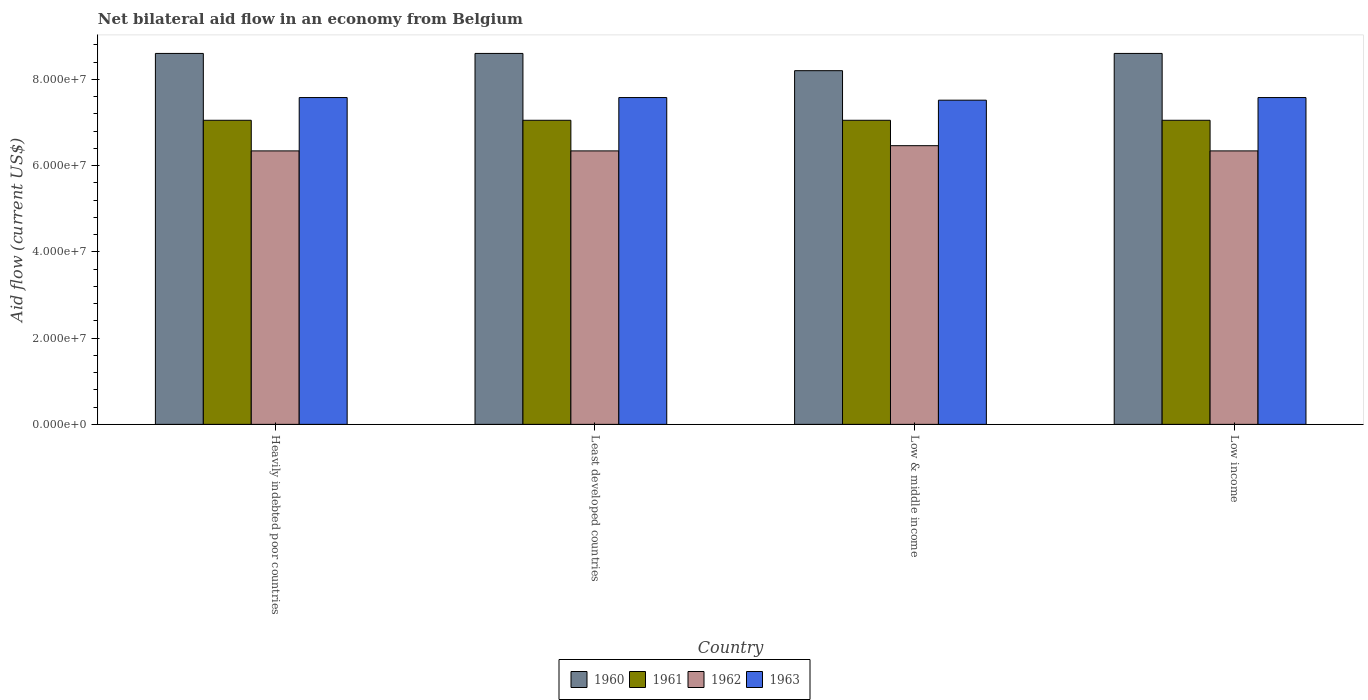How many different coloured bars are there?
Your answer should be compact. 4. Are the number of bars on each tick of the X-axis equal?
Ensure brevity in your answer.  Yes. How many bars are there on the 1st tick from the left?
Your answer should be compact. 4. How many bars are there on the 3rd tick from the right?
Your response must be concise. 4. What is the label of the 1st group of bars from the left?
Your response must be concise. Heavily indebted poor countries. In how many cases, is the number of bars for a given country not equal to the number of legend labels?
Provide a short and direct response. 0. What is the net bilateral aid flow in 1962 in Least developed countries?
Your response must be concise. 6.34e+07. Across all countries, what is the maximum net bilateral aid flow in 1961?
Ensure brevity in your answer.  7.05e+07. Across all countries, what is the minimum net bilateral aid flow in 1963?
Ensure brevity in your answer.  7.52e+07. In which country was the net bilateral aid flow in 1962 maximum?
Ensure brevity in your answer.  Low & middle income. What is the total net bilateral aid flow in 1963 in the graph?
Give a very brief answer. 3.02e+08. What is the difference between the net bilateral aid flow in 1962 in Low & middle income and the net bilateral aid flow in 1961 in Heavily indebted poor countries?
Offer a terse response. -5.89e+06. What is the average net bilateral aid flow in 1961 per country?
Keep it short and to the point. 7.05e+07. What is the difference between the net bilateral aid flow of/in 1961 and net bilateral aid flow of/in 1960 in Low & middle income?
Provide a succinct answer. -1.15e+07. In how many countries, is the net bilateral aid flow in 1960 greater than 52000000 US$?
Your response must be concise. 4. Is the net bilateral aid flow in 1962 in Least developed countries less than that in Low & middle income?
Offer a terse response. Yes. What is the difference between the highest and the second highest net bilateral aid flow in 1962?
Your response must be concise. 1.21e+06. What is the difference between the highest and the lowest net bilateral aid flow in 1961?
Your answer should be compact. 0. In how many countries, is the net bilateral aid flow in 1961 greater than the average net bilateral aid flow in 1961 taken over all countries?
Provide a short and direct response. 0. Is the sum of the net bilateral aid flow in 1962 in Low & middle income and Low income greater than the maximum net bilateral aid flow in 1961 across all countries?
Provide a short and direct response. Yes. What does the 4th bar from the left in Least developed countries represents?
Your response must be concise. 1963. How many bars are there?
Make the answer very short. 16. Are all the bars in the graph horizontal?
Keep it short and to the point. No. How many countries are there in the graph?
Your response must be concise. 4. Does the graph contain any zero values?
Keep it short and to the point. No. What is the title of the graph?
Your answer should be compact. Net bilateral aid flow in an economy from Belgium. Does "2000" appear as one of the legend labels in the graph?
Provide a succinct answer. No. What is the label or title of the X-axis?
Your answer should be compact. Country. What is the Aid flow (current US$) of 1960 in Heavily indebted poor countries?
Ensure brevity in your answer.  8.60e+07. What is the Aid flow (current US$) of 1961 in Heavily indebted poor countries?
Your answer should be compact. 7.05e+07. What is the Aid flow (current US$) of 1962 in Heavily indebted poor countries?
Provide a succinct answer. 6.34e+07. What is the Aid flow (current US$) in 1963 in Heavily indebted poor countries?
Give a very brief answer. 7.58e+07. What is the Aid flow (current US$) in 1960 in Least developed countries?
Your answer should be very brief. 8.60e+07. What is the Aid flow (current US$) of 1961 in Least developed countries?
Your answer should be very brief. 7.05e+07. What is the Aid flow (current US$) in 1962 in Least developed countries?
Give a very brief answer. 6.34e+07. What is the Aid flow (current US$) in 1963 in Least developed countries?
Give a very brief answer. 7.58e+07. What is the Aid flow (current US$) in 1960 in Low & middle income?
Offer a terse response. 8.20e+07. What is the Aid flow (current US$) in 1961 in Low & middle income?
Give a very brief answer. 7.05e+07. What is the Aid flow (current US$) in 1962 in Low & middle income?
Your answer should be very brief. 6.46e+07. What is the Aid flow (current US$) of 1963 in Low & middle income?
Your answer should be compact. 7.52e+07. What is the Aid flow (current US$) of 1960 in Low income?
Provide a short and direct response. 8.60e+07. What is the Aid flow (current US$) of 1961 in Low income?
Provide a short and direct response. 7.05e+07. What is the Aid flow (current US$) of 1962 in Low income?
Make the answer very short. 6.34e+07. What is the Aid flow (current US$) of 1963 in Low income?
Your response must be concise. 7.58e+07. Across all countries, what is the maximum Aid flow (current US$) in 1960?
Keep it short and to the point. 8.60e+07. Across all countries, what is the maximum Aid flow (current US$) in 1961?
Ensure brevity in your answer.  7.05e+07. Across all countries, what is the maximum Aid flow (current US$) in 1962?
Offer a very short reply. 6.46e+07. Across all countries, what is the maximum Aid flow (current US$) in 1963?
Provide a succinct answer. 7.58e+07. Across all countries, what is the minimum Aid flow (current US$) in 1960?
Offer a very short reply. 8.20e+07. Across all countries, what is the minimum Aid flow (current US$) of 1961?
Offer a very short reply. 7.05e+07. Across all countries, what is the minimum Aid flow (current US$) in 1962?
Make the answer very short. 6.34e+07. Across all countries, what is the minimum Aid flow (current US$) of 1963?
Your response must be concise. 7.52e+07. What is the total Aid flow (current US$) of 1960 in the graph?
Offer a very short reply. 3.40e+08. What is the total Aid flow (current US$) of 1961 in the graph?
Give a very brief answer. 2.82e+08. What is the total Aid flow (current US$) of 1962 in the graph?
Offer a very short reply. 2.55e+08. What is the total Aid flow (current US$) of 1963 in the graph?
Your response must be concise. 3.02e+08. What is the difference between the Aid flow (current US$) in 1962 in Heavily indebted poor countries and that in Least developed countries?
Provide a succinct answer. 0. What is the difference between the Aid flow (current US$) in 1961 in Heavily indebted poor countries and that in Low & middle income?
Your answer should be very brief. 0. What is the difference between the Aid flow (current US$) of 1962 in Heavily indebted poor countries and that in Low & middle income?
Your answer should be very brief. -1.21e+06. What is the difference between the Aid flow (current US$) of 1963 in Heavily indebted poor countries and that in Low & middle income?
Your answer should be very brief. 6.10e+05. What is the difference between the Aid flow (current US$) in 1960 in Heavily indebted poor countries and that in Low income?
Provide a short and direct response. 0. What is the difference between the Aid flow (current US$) of 1961 in Heavily indebted poor countries and that in Low income?
Provide a succinct answer. 0. What is the difference between the Aid flow (current US$) in 1962 in Least developed countries and that in Low & middle income?
Ensure brevity in your answer.  -1.21e+06. What is the difference between the Aid flow (current US$) of 1963 in Least developed countries and that in Low & middle income?
Ensure brevity in your answer.  6.10e+05. What is the difference between the Aid flow (current US$) of 1962 in Least developed countries and that in Low income?
Your answer should be very brief. 0. What is the difference between the Aid flow (current US$) in 1962 in Low & middle income and that in Low income?
Offer a very short reply. 1.21e+06. What is the difference between the Aid flow (current US$) of 1963 in Low & middle income and that in Low income?
Your answer should be very brief. -6.10e+05. What is the difference between the Aid flow (current US$) in 1960 in Heavily indebted poor countries and the Aid flow (current US$) in 1961 in Least developed countries?
Offer a terse response. 1.55e+07. What is the difference between the Aid flow (current US$) in 1960 in Heavily indebted poor countries and the Aid flow (current US$) in 1962 in Least developed countries?
Your answer should be very brief. 2.26e+07. What is the difference between the Aid flow (current US$) in 1960 in Heavily indebted poor countries and the Aid flow (current US$) in 1963 in Least developed countries?
Your answer should be very brief. 1.02e+07. What is the difference between the Aid flow (current US$) in 1961 in Heavily indebted poor countries and the Aid flow (current US$) in 1962 in Least developed countries?
Ensure brevity in your answer.  7.10e+06. What is the difference between the Aid flow (current US$) in 1961 in Heavily indebted poor countries and the Aid flow (current US$) in 1963 in Least developed countries?
Provide a short and direct response. -5.27e+06. What is the difference between the Aid flow (current US$) of 1962 in Heavily indebted poor countries and the Aid flow (current US$) of 1963 in Least developed countries?
Your answer should be very brief. -1.24e+07. What is the difference between the Aid flow (current US$) of 1960 in Heavily indebted poor countries and the Aid flow (current US$) of 1961 in Low & middle income?
Provide a short and direct response. 1.55e+07. What is the difference between the Aid flow (current US$) in 1960 in Heavily indebted poor countries and the Aid flow (current US$) in 1962 in Low & middle income?
Your answer should be compact. 2.14e+07. What is the difference between the Aid flow (current US$) in 1960 in Heavily indebted poor countries and the Aid flow (current US$) in 1963 in Low & middle income?
Offer a terse response. 1.08e+07. What is the difference between the Aid flow (current US$) in 1961 in Heavily indebted poor countries and the Aid flow (current US$) in 1962 in Low & middle income?
Keep it short and to the point. 5.89e+06. What is the difference between the Aid flow (current US$) of 1961 in Heavily indebted poor countries and the Aid flow (current US$) of 1963 in Low & middle income?
Provide a succinct answer. -4.66e+06. What is the difference between the Aid flow (current US$) of 1962 in Heavily indebted poor countries and the Aid flow (current US$) of 1963 in Low & middle income?
Offer a terse response. -1.18e+07. What is the difference between the Aid flow (current US$) in 1960 in Heavily indebted poor countries and the Aid flow (current US$) in 1961 in Low income?
Provide a short and direct response. 1.55e+07. What is the difference between the Aid flow (current US$) of 1960 in Heavily indebted poor countries and the Aid flow (current US$) of 1962 in Low income?
Provide a succinct answer. 2.26e+07. What is the difference between the Aid flow (current US$) in 1960 in Heavily indebted poor countries and the Aid flow (current US$) in 1963 in Low income?
Your answer should be compact. 1.02e+07. What is the difference between the Aid flow (current US$) in 1961 in Heavily indebted poor countries and the Aid flow (current US$) in 1962 in Low income?
Keep it short and to the point. 7.10e+06. What is the difference between the Aid flow (current US$) in 1961 in Heavily indebted poor countries and the Aid flow (current US$) in 1963 in Low income?
Ensure brevity in your answer.  -5.27e+06. What is the difference between the Aid flow (current US$) in 1962 in Heavily indebted poor countries and the Aid flow (current US$) in 1963 in Low income?
Keep it short and to the point. -1.24e+07. What is the difference between the Aid flow (current US$) in 1960 in Least developed countries and the Aid flow (current US$) in 1961 in Low & middle income?
Provide a succinct answer. 1.55e+07. What is the difference between the Aid flow (current US$) in 1960 in Least developed countries and the Aid flow (current US$) in 1962 in Low & middle income?
Give a very brief answer. 2.14e+07. What is the difference between the Aid flow (current US$) of 1960 in Least developed countries and the Aid flow (current US$) of 1963 in Low & middle income?
Your response must be concise. 1.08e+07. What is the difference between the Aid flow (current US$) in 1961 in Least developed countries and the Aid flow (current US$) in 1962 in Low & middle income?
Give a very brief answer. 5.89e+06. What is the difference between the Aid flow (current US$) of 1961 in Least developed countries and the Aid flow (current US$) of 1963 in Low & middle income?
Make the answer very short. -4.66e+06. What is the difference between the Aid flow (current US$) of 1962 in Least developed countries and the Aid flow (current US$) of 1963 in Low & middle income?
Your answer should be very brief. -1.18e+07. What is the difference between the Aid flow (current US$) of 1960 in Least developed countries and the Aid flow (current US$) of 1961 in Low income?
Give a very brief answer. 1.55e+07. What is the difference between the Aid flow (current US$) of 1960 in Least developed countries and the Aid flow (current US$) of 1962 in Low income?
Provide a succinct answer. 2.26e+07. What is the difference between the Aid flow (current US$) in 1960 in Least developed countries and the Aid flow (current US$) in 1963 in Low income?
Make the answer very short. 1.02e+07. What is the difference between the Aid flow (current US$) in 1961 in Least developed countries and the Aid flow (current US$) in 1962 in Low income?
Offer a terse response. 7.10e+06. What is the difference between the Aid flow (current US$) in 1961 in Least developed countries and the Aid flow (current US$) in 1963 in Low income?
Make the answer very short. -5.27e+06. What is the difference between the Aid flow (current US$) of 1962 in Least developed countries and the Aid flow (current US$) of 1963 in Low income?
Offer a terse response. -1.24e+07. What is the difference between the Aid flow (current US$) of 1960 in Low & middle income and the Aid flow (current US$) of 1961 in Low income?
Give a very brief answer. 1.15e+07. What is the difference between the Aid flow (current US$) of 1960 in Low & middle income and the Aid flow (current US$) of 1962 in Low income?
Your answer should be very brief. 1.86e+07. What is the difference between the Aid flow (current US$) in 1960 in Low & middle income and the Aid flow (current US$) in 1963 in Low income?
Your answer should be very brief. 6.23e+06. What is the difference between the Aid flow (current US$) in 1961 in Low & middle income and the Aid flow (current US$) in 1962 in Low income?
Make the answer very short. 7.10e+06. What is the difference between the Aid flow (current US$) in 1961 in Low & middle income and the Aid flow (current US$) in 1963 in Low income?
Your answer should be compact. -5.27e+06. What is the difference between the Aid flow (current US$) in 1962 in Low & middle income and the Aid flow (current US$) in 1963 in Low income?
Give a very brief answer. -1.12e+07. What is the average Aid flow (current US$) in 1960 per country?
Your answer should be very brief. 8.50e+07. What is the average Aid flow (current US$) of 1961 per country?
Offer a very short reply. 7.05e+07. What is the average Aid flow (current US$) in 1962 per country?
Give a very brief answer. 6.37e+07. What is the average Aid flow (current US$) of 1963 per country?
Keep it short and to the point. 7.56e+07. What is the difference between the Aid flow (current US$) in 1960 and Aid flow (current US$) in 1961 in Heavily indebted poor countries?
Make the answer very short. 1.55e+07. What is the difference between the Aid flow (current US$) of 1960 and Aid flow (current US$) of 1962 in Heavily indebted poor countries?
Provide a short and direct response. 2.26e+07. What is the difference between the Aid flow (current US$) in 1960 and Aid flow (current US$) in 1963 in Heavily indebted poor countries?
Make the answer very short. 1.02e+07. What is the difference between the Aid flow (current US$) of 1961 and Aid flow (current US$) of 1962 in Heavily indebted poor countries?
Keep it short and to the point. 7.10e+06. What is the difference between the Aid flow (current US$) in 1961 and Aid flow (current US$) in 1963 in Heavily indebted poor countries?
Ensure brevity in your answer.  -5.27e+06. What is the difference between the Aid flow (current US$) of 1962 and Aid flow (current US$) of 1963 in Heavily indebted poor countries?
Provide a short and direct response. -1.24e+07. What is the difference between the Aid flow (current US$) in 1960 and Aid flow (current US$) in 1961 in Least developed countries?
Keep it short and to the point. 1.55e+07. What is the difference between the Aid flow (current US$) of 1960 and Aid flow (current US$) of 1962 in Least developed countries?
Your answer should be very brief. 2.26e+07. What is the difference between the Aid flow (current US$) of 1960 and Aid flow (current US$) of 1963 in Least developed countries?
Offer a very short reply. 1.02e+07. What is the difference between the Aid flow (current US$) in 1961 and Aid flow (current US$) in 1962 in Least developed countries?
Offer a very short reply. 7.10e+06. What is the difference between the Aid flow (current US$) of 1961 and Aid flow (current US$) of 1963 in Least developed countries?
Your answer should be very brief. -5.27e+06. What is the difference between the Aid flow (current US$) of 1962 and Aid flow (current US$) of 1963 in Least developed countries?
Provide a succinct answer. -1.24e+07. What is the difference between the Aid flow (current US$) in 1960 and Aid flow (current US$) in 1961 in Low & middle income?
Provide a succinct answer. 1.15e+07. What is the difference between the Aid flow (current US$) in 1960 and Aid flow (current US$) in 1962 in Low & middle income?
Provide a short and direct response. 1.74e+07. What is the difference between the Aid flow (current US$) in 1960 and Aid flow (current US$) in 1963 in Low & middle income?
Make the answer very short. 6.84e+06. What is the difference between the Aid flow (current US$) in 1961 and Aid flow (current US$) in 1962 in Low & middle income?
Provide a succinct answer. 5.89e+06. What is the difference between the Aid flow (current US$) of 1961 and Aid flow (current US$) of 1963 in Low & middle income?
Give a very brief answer. -4.66e+06. What is the difference between the Aid flow (current US$) of 1962 and Aid flow (current US$) of 1963 in Low & middle income?
Give a very brief answer. -1.06e+07. What is the difference between the Aid flow (current US$) in 1960 and Aid flow (current US$) in 1961 in Low income?
Your answer should be very brief. 1.55e+07. What is the difference between the Aid flow (current US$) in 1960 and Aid flow (current US$) in 1962 in Low income?
Ensure brevity in your answer.  2.26e+07. What is the difference between the Aid flow (current US$) in 1960 and Aid flow (current US$) in 1963 in Low income?
Your answer should be compact. 1.02e+07. What is the difference between the Aid flow (current US$) in 1961 and Aid flow (current US$) in 1962 in Low income?
Provide a succinct answer. 7.10e+06. What is the difference between the Aid flow (current US$) in 1961 and Aid flow (current US$) in 1963 in Low income?
Your response must be concise. -5.27e+06. What is the difference between the Aid flow (current US$) of 1962 and Aid flow (current US$) of 1963 in Low income?
Offer a very short reply. -1.24e+07. What is the ratio of the Aid flow (current US$) of 1961 in Heavily indebted poor countries to that in Least developed countries?
Your answer should be very brief. 1. What is the ratio of the Aid flow (current US$) in 1960 in Heavily indebted poor countries to that in Low & middle income?
Make the answer very short. 1.05. What is the ratio of the Aid flow (current US$) of 1962 in Heavily indebted poor countries to that in Low & middle income?
Ensure brevity in your answer.  0.98. What is the ratio of the Aid flow (current US$) in 1960 in Heavily indebted poor countries to that in Low income?
Provide a short and direct response. 1. What is the ratio of the Aid flow (current US$) in 1961 in Heavily indebted poor countries to that in Low income?
Your response must be concise. 1. What is the ratio of the Aid flow (current US$) in 1962 in Heavily indebted poor countries to that in Low income?
Give a very brief answer. 1. What is the ratio of the Aid flow (current US$) in 1963 in Heavily indebted poor countries to that in Low income?
Provide a succinct answer. 1. What is the ratio of the Aid flow (current US$) in 1960 in Least developed countries to that in Low & middle income?
Give a very brief answer. 1.05. What is the ratio of the Aid flow (current US$) in 1961 in Least developed countries to that in Low & middle income?
Your answer should be compact. 1. What is the ratio of the Aid flow (current US$) of 1962 in Least developed countries to that in Low & middle income?
Make the answer very short. 0.98. What is the ratio of the Aid flow (current US$) in 1963 in Least developed countries to that in Low & middle income?
Offer a very short reply. 1.01. What is the ratio of the Aid flow (current US$) in 1961 in Least developed countries to that in Low income?
Provide a short and direct response. 1. What is the ratio of the Aid flow (current US$) in 1963 in Least developed countries to that in Low income?
Keep it short and to the point. 1. What is the ratio of the Aid flow (current US$) of 1960 in Low & middle income to that in Low income?
Provide a short and direct response. 0.95. What is the ratio of the Aid flow (current US$) of 1962 in Low & middle income to that in Low income?
Offer a terse response. 1.02. What is the ratio of the Aid flow (current US$) in 1963 in Low & middle income to that in Low income?
Make the answer very short. 0.99. What is the difference between the highest and the second highest Aid flow (current US$) of 1960?
Your answer should be compact. 0. What is the difference between the highest and the second highest Aid flow (current US$) in 1962?
Make the answer very short. 1.21e+06. What is the difference between the highest and the lowest Aid flow (current US$) in 1960?
Make the answer very short. 4.00e+06. What is the difference between the highest and the lowest Aid flow (current US$) in 1962?
Keep it short and to the point. 1.21e+06. What is the difference between the highest and the lowest Aid flow (current US$) of 1963?
Offer a terse response. 6.10e+05. 